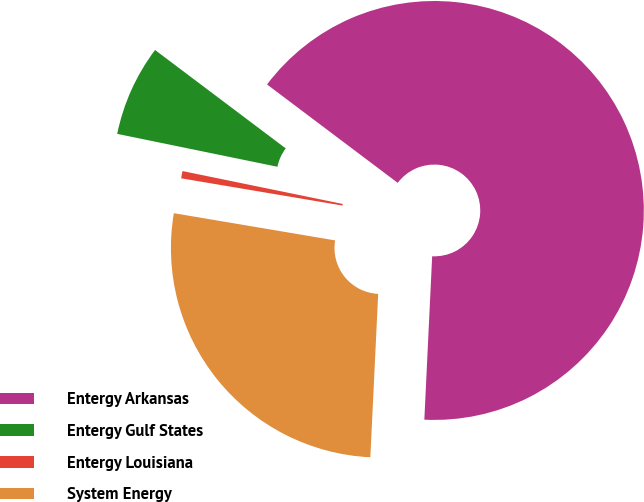Convert chart to OTSL. <chart><loc_0><loc_0><loc_500><loc_500><pie_chart><fcel>Entergy Arkansas<fcel>Entergy Gulf States<fcel>Entergy Louisiana<fcel>System Energy<nl><fcel>65.49%<fcel>7.05%<fcel>0.56%<fcel>26.9%<nl></chart> 